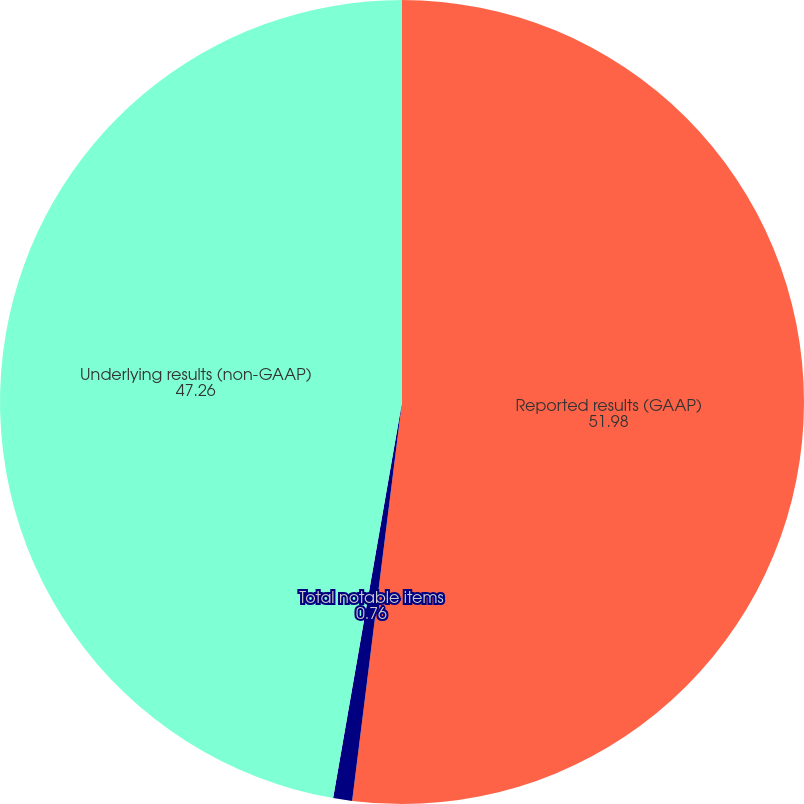Convert chart. <chart><loc_0><loc_0><loc_500><loc_500><pie_chart><fcel>Reported results (GAAP)<fcel>Total notable items<fcel>Underlying results (non-GAAP)<nl><fcel>51.98%<fcel>0.76%<fcel>47.26%<nl></chart> 